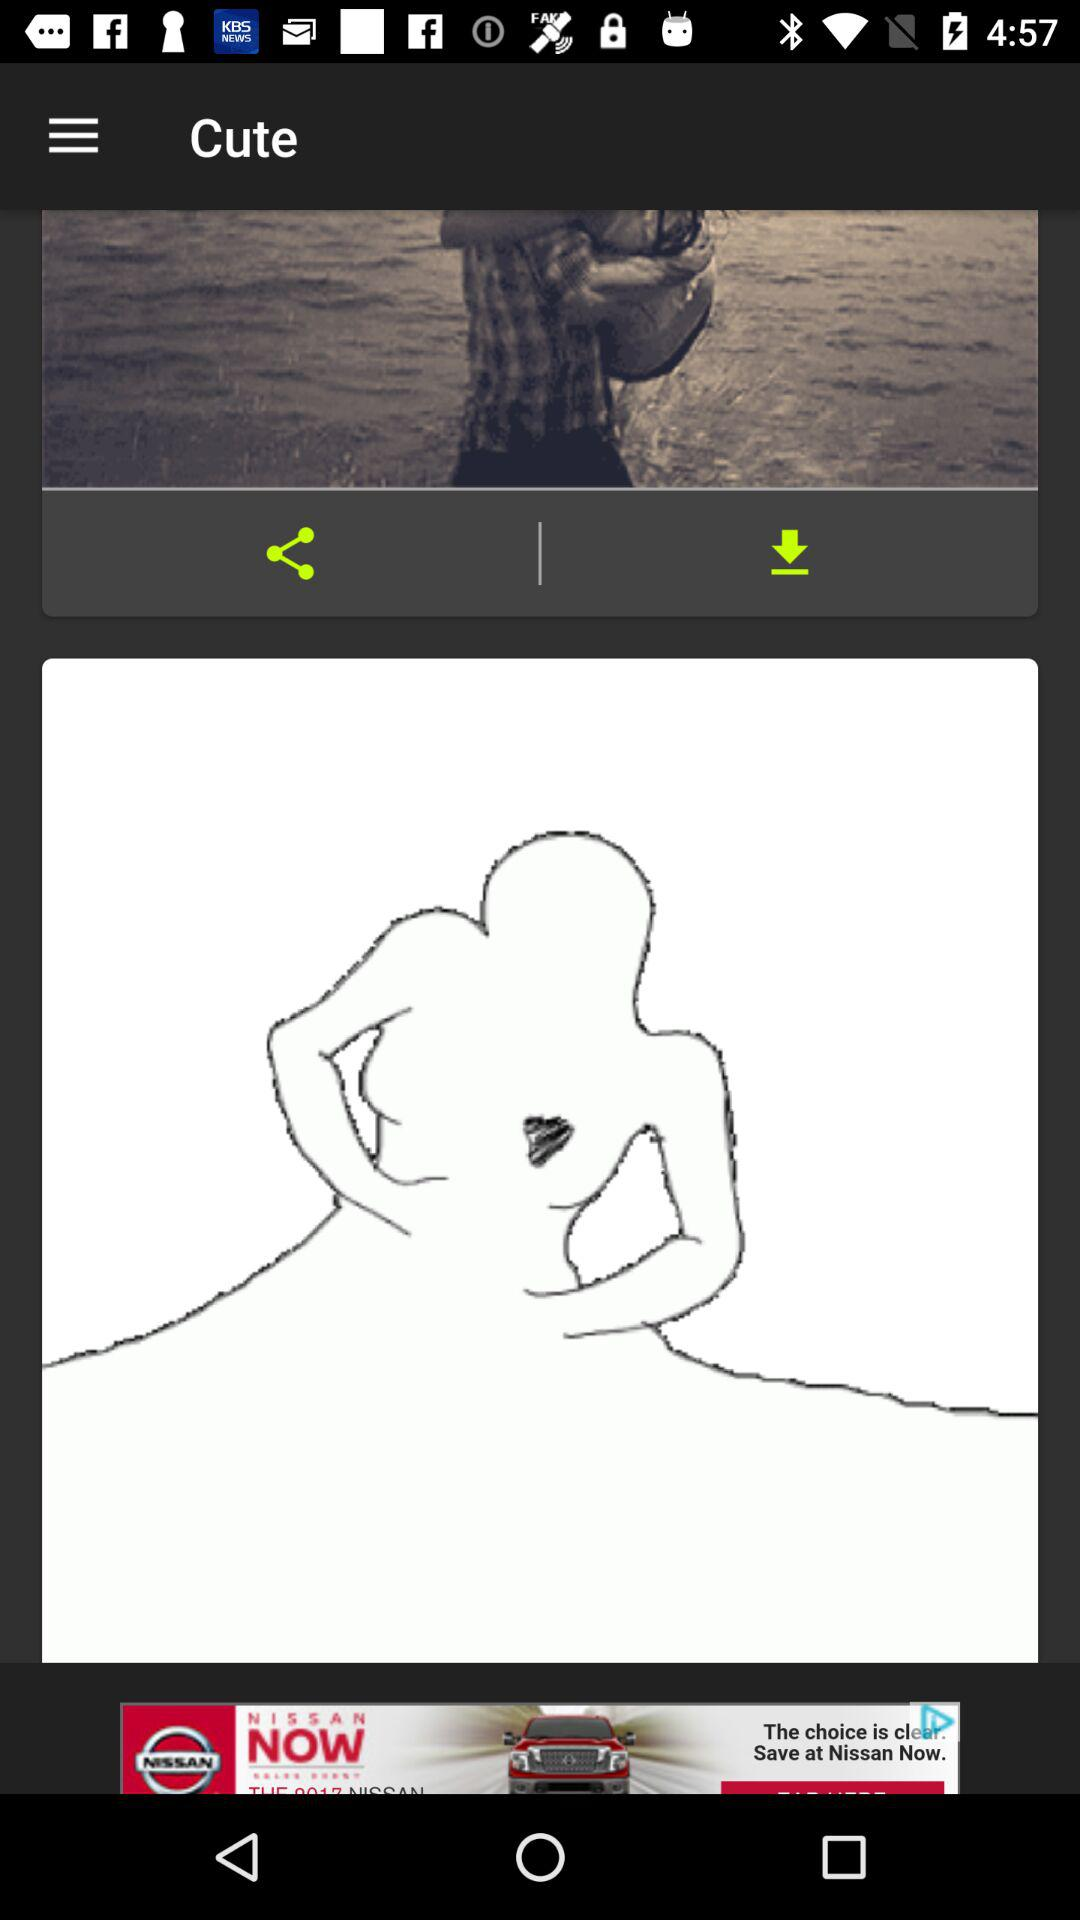What is the name of this image?
When the provided information is insufficient, respond with <no answer>. <no answer> 